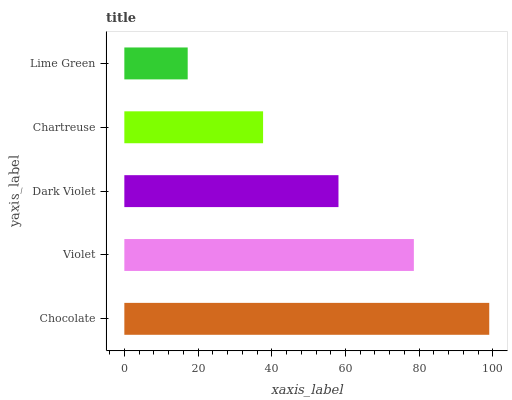Is Lime Green the minimum?
Answer yes or no. Yes. Is Chocolate the maximum?
Answer yes or no. Yes. Is Violet the minimum?
Answer yes or no. No. Is Violet the maximum?
Answer yes or no. No. Is Chocolate greater than Violet?
Answer yes or no. Yes. Is Violet less than Chocolate?
Answer yes or no. Yes. Is Violet greater than Chocolate?
Answer yes or no. No. Is Chocolate less than Violet?
Answer yes or no. No. Is Dark Violet the high median?
Answer yes or no. Yes. Is Dark Violet the low median?
Answer yes or no. Yes. Is Violet the high median?
Answer yes or no. No. Is Lime Green the low median?
Answer yes or no. No. 